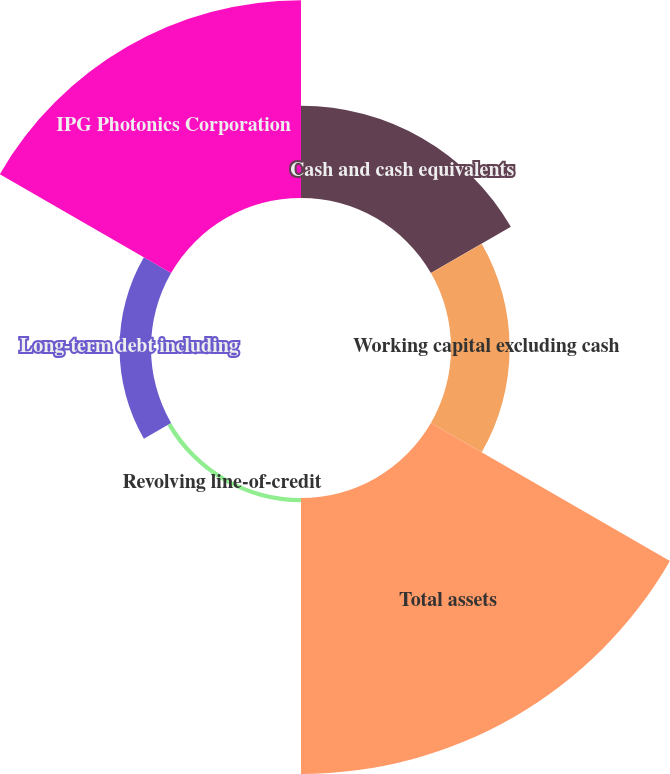Convert chart to OTSL. <chart><loc_0><loc_0><loc_500><loc_500><pie_chart><fcel>Cash and cash equivalents<fcel>Working capital excluding cash<fcel>Total assets<fcel>Revolving line-of-credit<fcel>Long-term debt including<fcel>IPG Photonics Corporation<nl><fcel>13.98%<fcel>8.88%<fcel>41.79%<fcel>0.65%<fcel>4.76%<fcel>29.94%<nl></chart> 